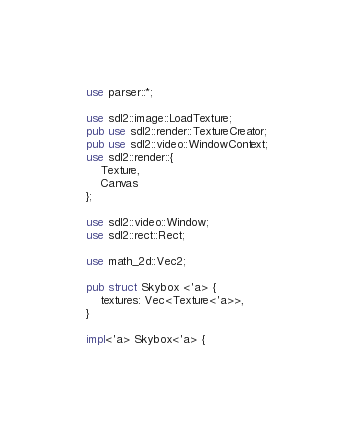Convert code to text. <code><loc_0><loc_0><loc_500><loc_500><_Rust_>use parser::*;

use sdl2::image::LoadTexture;
pub use sdl2::render::TextureCreator;
pub use sdl2::video::WindowContext;
use sdl2::render::{
    Texture,
    Canvas
};

use sdl2::video::Window;
use sdl2::rect::Rect;

use math_2d::Vec2;

pub struct Skybox <'a> {
    textures: Vec<Texture<'a>>,
}

impl<'a> Skybox<'a> {</code> 